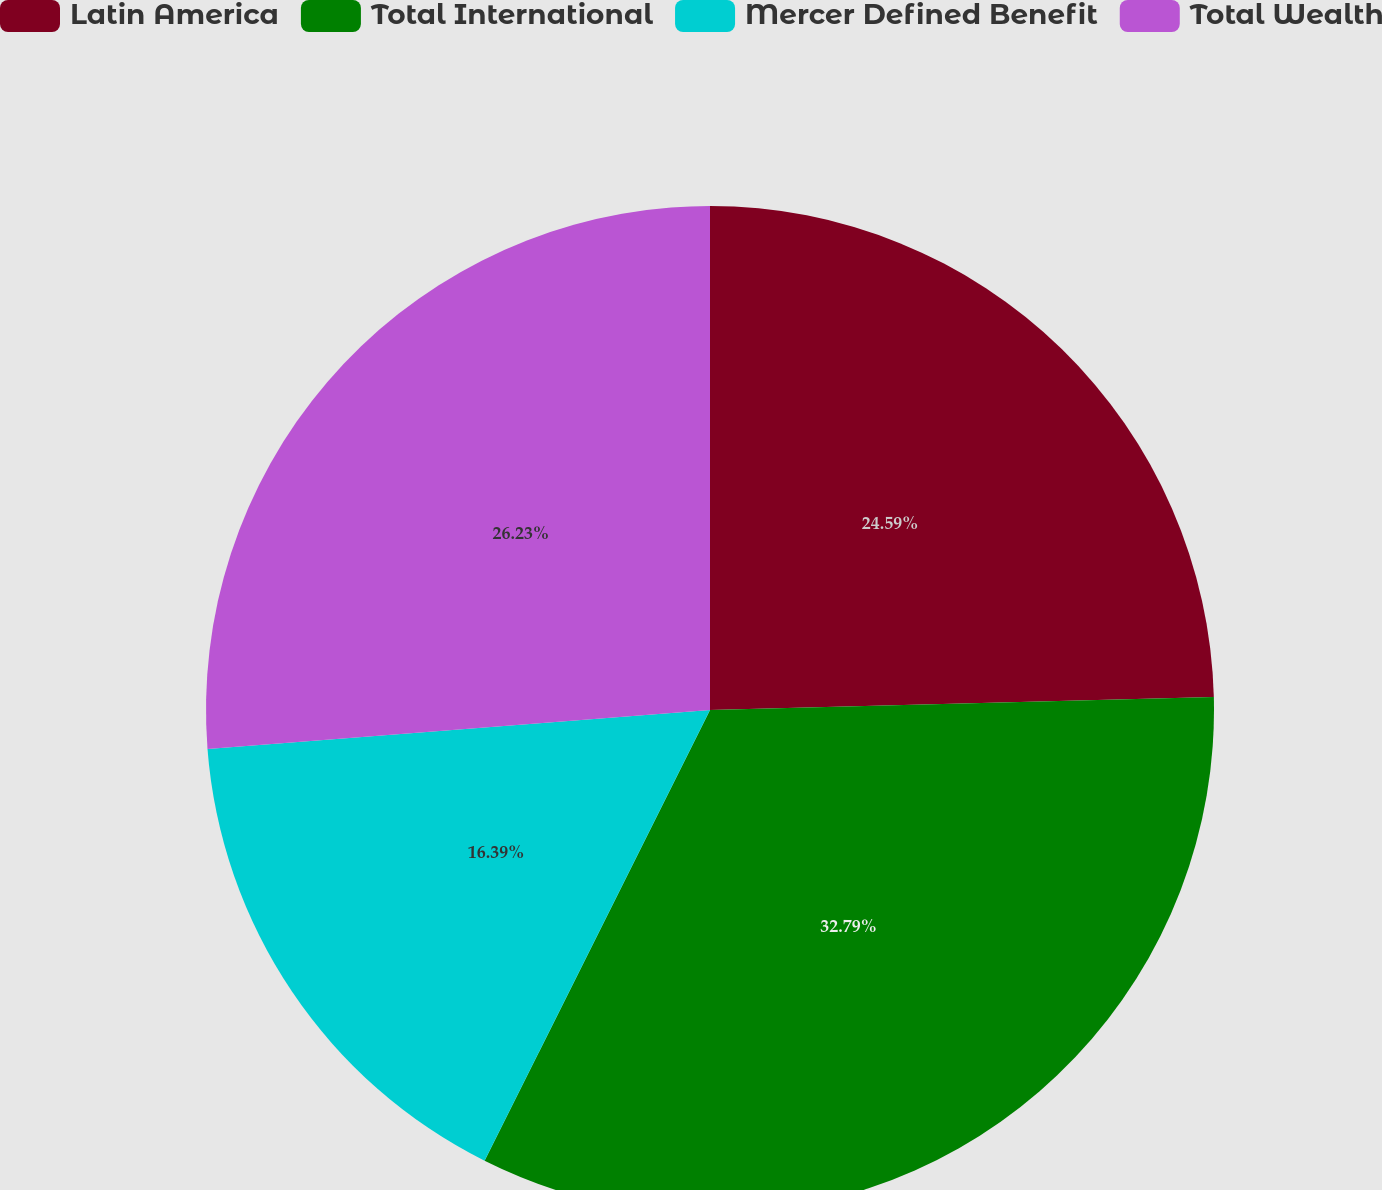Convert chart to OTSL. <chart><loc_0><loc_0><loc_500><loc_500><pie_chart><fcel>Latin America<fcel>Total International<fcel>Mercer Defined Benefit<fcel>Total Wealth<nl><fcel>24.59%<fcel>32.79%<fcel>16.39%<fcel>26.23%<nl></chart> 